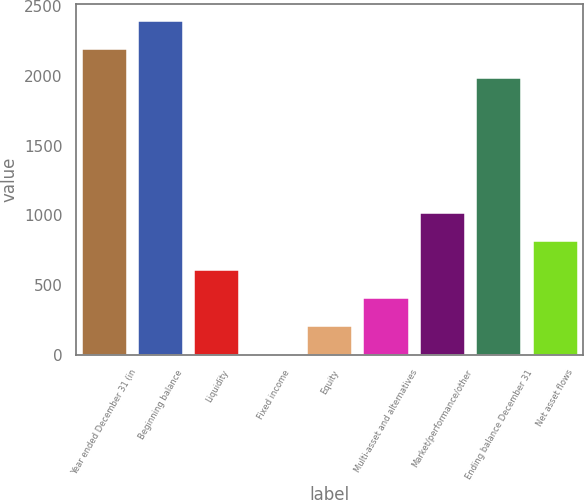Convert chart to OTSL. <chart><loc_0><loc_0><loc_500><loc_500><bar_chart><fcel>Year ended December 31 (in<fcel>Beginning balance<fcel>Liquidity<fcel>Fixed income<fcel>Equity<fcel>Multi-asset and alternatives<fcel>Market/performance/other<fcel>Ending balance December 31<fcel>Net asset flows<nl><fcel>2190.3<fcel>2393.6<fcel>610.9<fcel>1<fcel>204.3<fcel>407.6<fcel>1017.5<fcel>1987<fcel>814.2<nl></chart> 